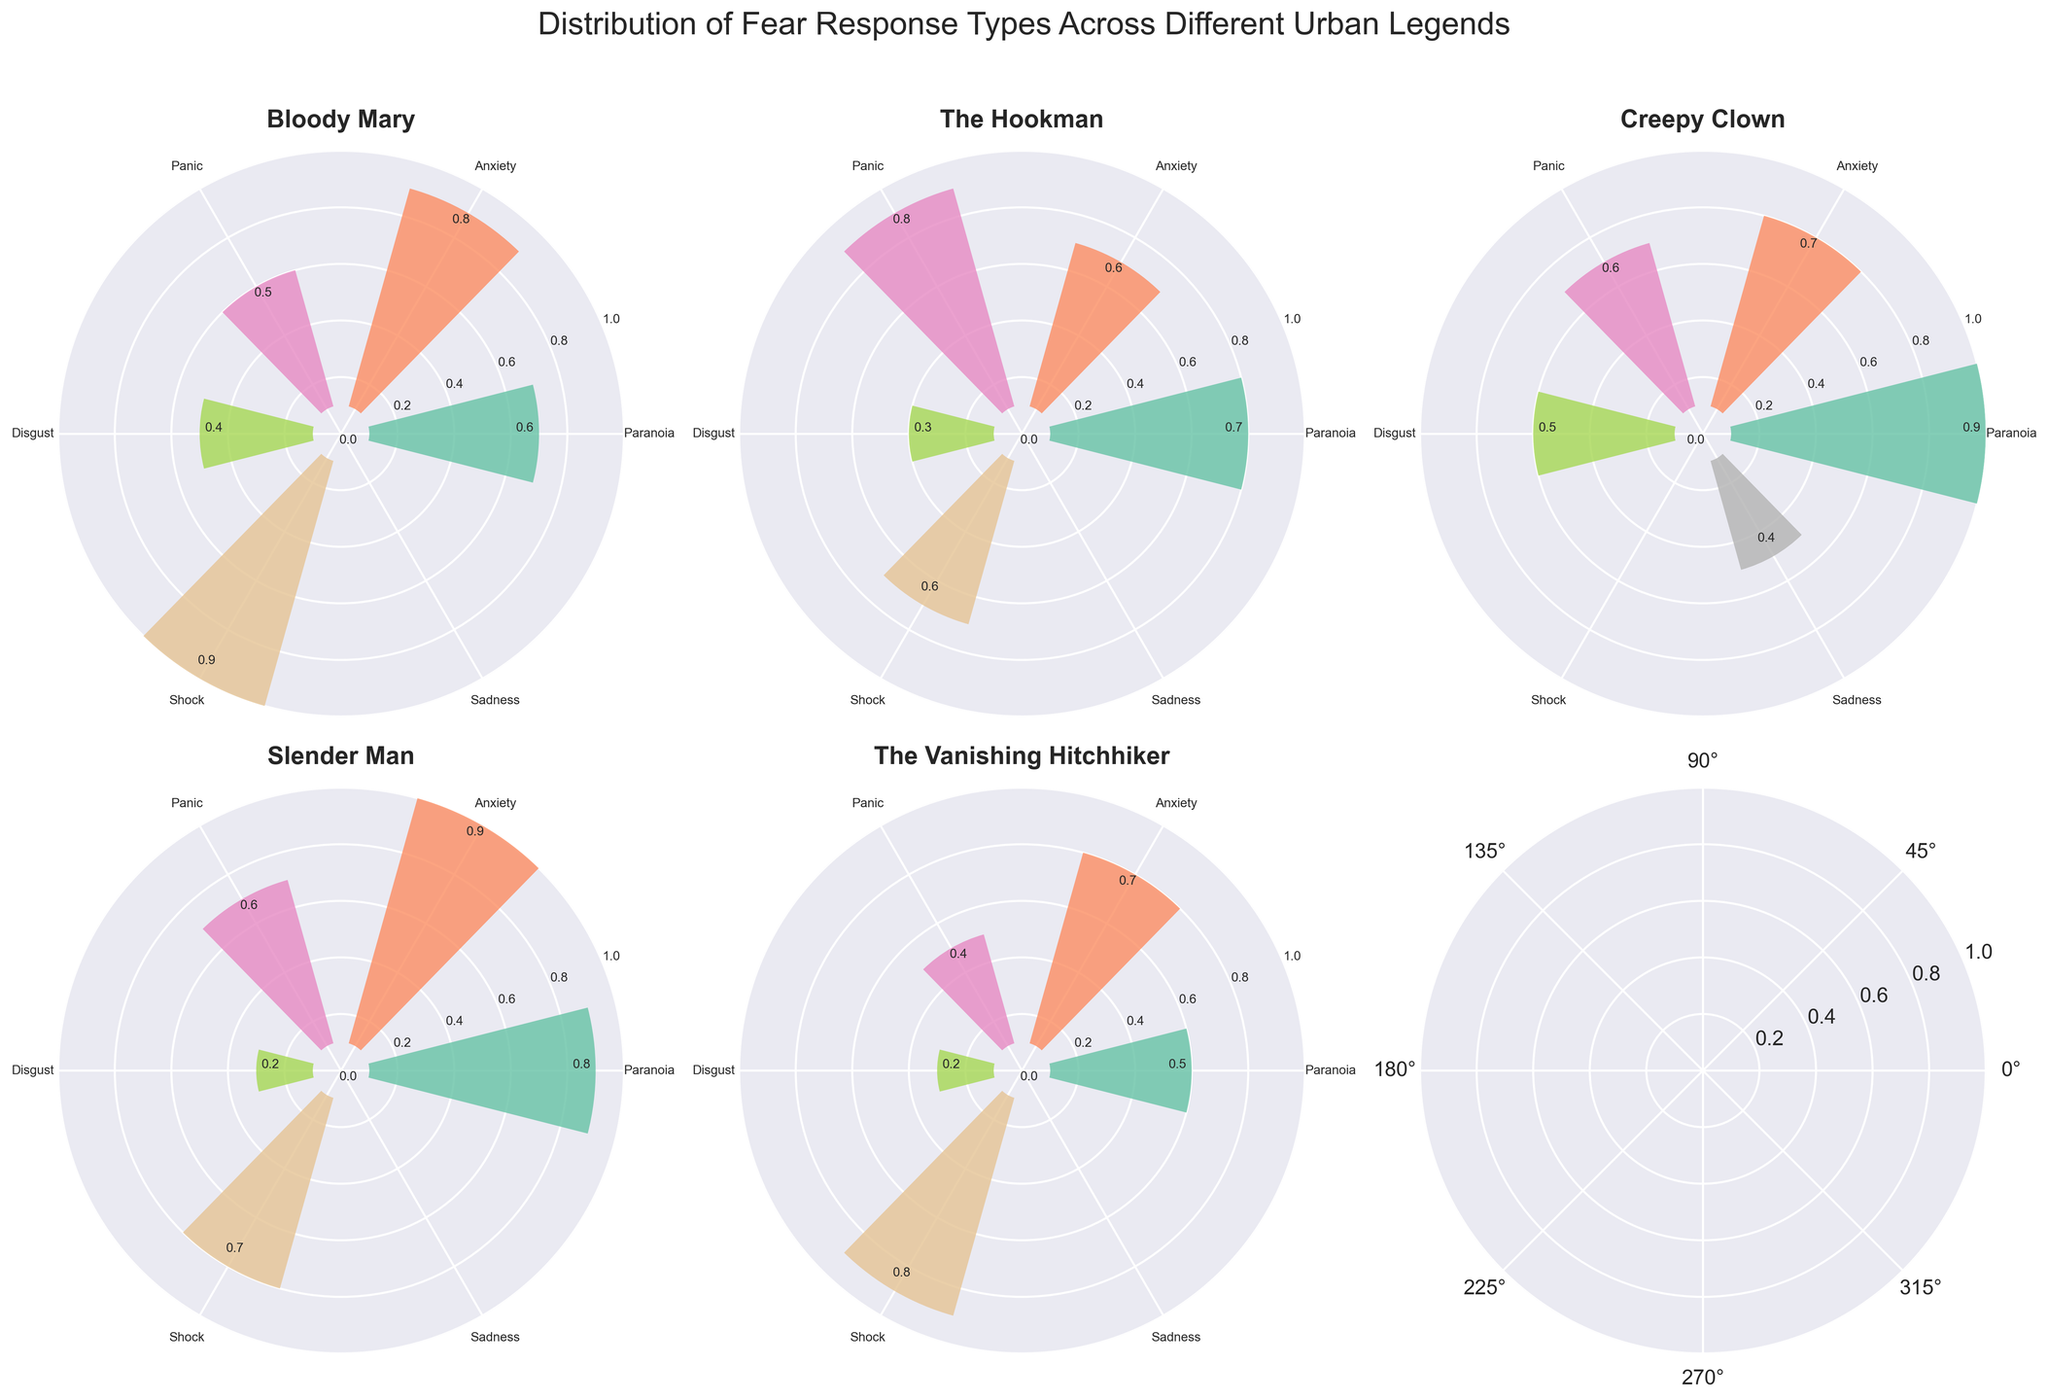What is the intensity value of Paranoia for Bloody Mary? Look at the polar plot for Bloody Mary and find the bar that corresponds to Paranoia. The height value shows the intensity, which is 0.6.
Answer: 0.6 Which urban legend has the highest intensity for Anxiety? Check each subplot and find the maximum bar in each for Anxiety. Bloody Mary has 0.8, The Hookman has 0.6, Creepy Clown has 0.7, Slender Man has 0.9, and The Vanishing Hitchhiker has 0.7. Slender Man has the highest intensity at 0.9.
Answer: Slender Man What is the average intensity of Panic across all urban legends? Add the Panic intensities of all urban legends: Bloody Mary (0.5), The Hookman (0.8), Creepy Clown (0.6), Slender Man (0.6), and The Vanishing Hitchhiker (0.4). Then, divide the total by the number of legends: (0.5 + 0.8 + 0.6 + 0.6 + 0.4) / 5.
Answer: 0.58 Which urban legend shows the highest intensity for Disgust? Find the bar heights labeled Disgust in each subplot. Bloody Mary (0.4), The Hookman (0.3), Creepy Clown (0.5), Slender Man (0.2), and The Vanishing Hitchhiker (0.2). Creepy Clown has the highest intensity at 0.5.
Answer: Creepy Clown How does the intensity of Shock for The Hookman compare to that of Bloody Mary? Compare the bar labeled Shock for both legends. The Hookman has 0.6, and Bloody Mary has 0.9. 0.6 < 0.9.
Answer: Lower Which urban legend has the broadest range of fear response types? Identify the number of unique fear response types for each legend from the subplots: Bloody Mary (5), The Hookman (5), Creepy Clown (5), Slender Man (5), and The Vanishing Hitchhiker (5). All have 5 types, hence the same range.
Answer: All legends What is the total intensity of Paranoia for all urban legends combined? Add the Paranoia intensities from all subplots: Bloody Mary (0.6), The Hookman (0.7), Creepy Clown (0.9), Slender Man (0.8), and The Vanishing Hitchhiker (0.5). (0.6 + 0.7 + 0.9 + 0.8 + 0.5).
Answer: 3.5 Which fear response type has the lowest overall intensity in Slender Man? Look at all the bars for Slender Man to find the lowest intensity: Paranoia (0.8), Anxiety (0.9), Panic (0.6), Disgust (0.2), and Shock (0.7). Disgust is the lowest at 0.2.
Answer: Disgust 